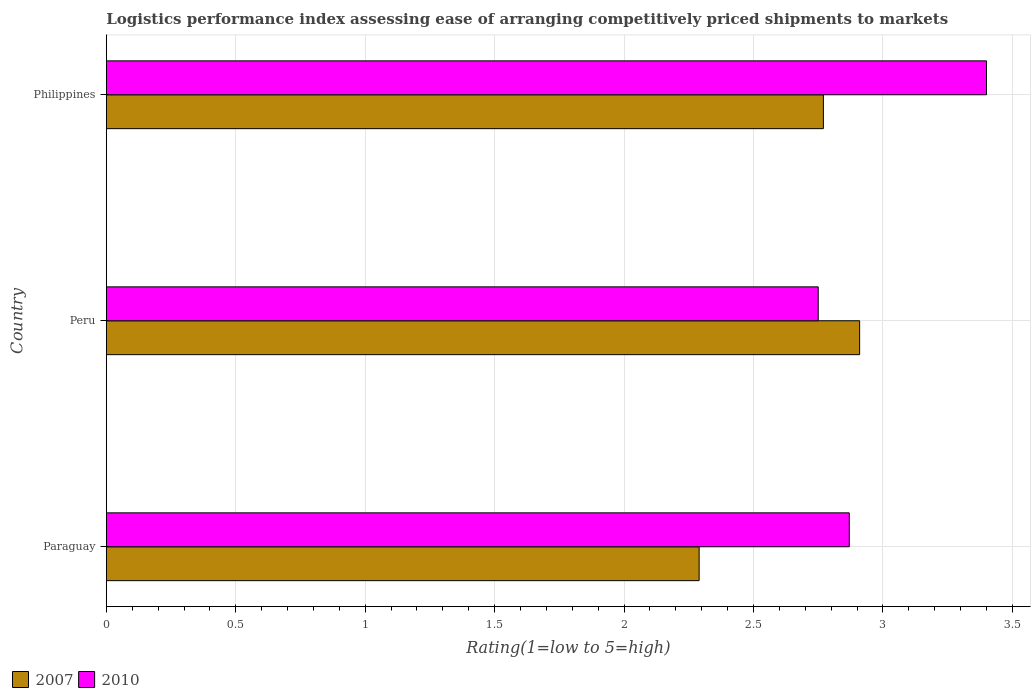Are the number of bars per tick equal to the number of legend labels?
Offer a very short reply. Yes. Are the number of bars on each tick of the Y-axis equal?
Offer a very short reply. Yes. How many bars are there on the 3rd tick from the top?
Give a very brief answer. 2. How many bars are there on the 3rd tick from the bottom?
Make the answer very short. 2. What is the label of the 3rd group of bars from the top?
Provide a succinct answer. Paraguay. What is the Logistic performance index in 2007 in Philippines?
Make the answer very short. 2.77. Across all countries, what is the minimum Logistic performance index in 2007?
Your answer should be compact. 2.29. In which country was the Logistic performance index in 2010 minimum?
Make the answer very short. Peru. What is the total Logistic performance index in 2010 in the graph?
Offer a very short reply. 9.02. What is the difference between the Logistic performance index in 2010 in Peru and that in Philippines?
Provide a succinct answer. -0.65. What is the difference between the Logistic performance index in 2007 in Paraguay and the Logistic performance index in 2010 in Peru?
Provide a short and direct response. -0.46. What is the average Logistic performance index in 2010 per country?
Provide a short and direct response. 3.01. What is the difference between the Logistic performance index in 2010 and Logistic performance index in 2007 in Philippines?
Make the answer very short. 0.63. What is the ratio of the Logistic performance index in 2010 in Paraguay to that in Peru?
Your response must be concise. 1.04. Is the Logistic performance index in 2007 in Peru less than that in Philippines?
Make the answer very short. No. What is the difference between the highest and the second highest Logistic performance index in 2007?
Ensure brevity in your answer.  0.14. What is the difference between the highest and the lowest Logistic performance index in 2007?
Your response must be concise. 0.62. In how many countries, is the Logistic performance index in 2010 greater than the average Logistic performance index in 2010 taken over all countries?
Give a very brief answer. 1. How many bars are there?
Offer a terse response. 6. How many countries are there in the graph?
Your answer should be very brief. 3. What is the difference between two consecutive major ticks on the X-axis?
Ensure brevity in your answer.  0.5. Does the graph contain grids?
Ensure brevity in your answer.  Yes. Where does the legend appear in the graph?
Keep it short and to the point. Bottom left. How many legend labels are there?
Keep it short and to the point. 2. What is the title of the graph?
Your response must be concise. Logistics performance index assessing ease of arranging competitively priced shipments to markets. What is the label or title of the X-axis?
Your answer should be compact. Rating(1=low to 5=high). What is the Rating(1=low to 5=high) of 2007 in Paraguay?
Provide a succinct answer. 2.29. What is the Rating(1=low to 5=high) of 2010 in Paraguay?
Your answer should be very brief. 2.87. What is the Rating(1=low to 5=high) in 2007 in Peru?
Your response must be concise. 2.91. What is the Rating(1=low to 5=high) of 2010 in Peru?
Your response must be concise. 2.75. What is the Rating(1=low to 5=high) in 2007 in Philippines?
Offer a very short reply. 2.77. Across all countries, what is the maximum Rating(1=low to 5=high) of 2007?
Your answer should be compact. 2.91. Across all countries, what is the maximum Rating(1=low to 5=high) of 2010?
Offer a very short reply. 3.4. Across all countries, what is the minimum Rating(1=low to 5=high) of 2007?
Your answer should be very brief. 2.29. Across all countries, what is the minimum Rating(1=low to 5=high) of 2010?
Offer a very short reply. 2.75. What is the total Rating(1=low to 5=high) of 2007 in the graph?
Make the answer very short. 7.97. What is the total Rating(1=low to 5=high) in 2010 in the graph?
Keep it short and to the point. 9.02. What is the difference between the Rating(1=low to 5=high) of 2007 in Paraguay and that in Peru?
Provide a short and direct response. -0.62. What is the difference between the Rating(1=low to 5=high) of 2010 in Paraguay and that in Peru?
Give a very brief answer. 0.12. What is the difference between the Rating(1=low to 5=high) in 2007 in Paraguay and that in Philippines?
Your response must be concise. -0.48. What is the difference between the Rating(1=low to 5=high) in 2010 in Paraguay and that in Philippines?
Provide a succinct answer. -0.53. What is the difference between the Rating(1=low to 5=high) of 2007 in Peru and that in Philippines?
Your answer should be very brief. 0.14. What is the difference between the Rating(1=low to 5=high) in 2010 in Peru and that in Philippines?
Provide a short and direct response. -0.65. What is the difference between the Rating(1=low to 5=high) in 2007 in Paraguay and the Rating(1=low to 5=high) in 2010 in Peru?
Provide a succinct answer. -0.46. What is the difference between the Rating(1=low to 5=high) in 2007 in Paraguay and the Rating(1=low to 5=high) in 2010 in Philippines?
Keep it short and to the point. -1.11. What is the difference between the Rating(1=low to 5=high) of 2007 in Peru and the Rating(1=low to 5=high) of 2010 in Philippines?
Provide a short and direct response. -0.49. What is the average Rating(1=low to 5=high) of 2007 per country?
Provide a succinct answer. 2.66. What is the average Rating(1=low to 5=high) of 2010 per country?
Your answer should be compact. 3.01. What is the difference between the Rating(1=low to 5=high) of 2007 and Rating(1=low to 5=high) of 2010 in Paraguay?
Your response must be concise. -0.58. What is the difference between the Rating(1=low to 5=high) of 2007 and Rating(1=low to 5=high) of 2010 in Peru?
Keep it short and to the point. 0.16. What is the difference between the Rating(1=low to 5=high) of 2007 and Rating(1=low to 5=high) of 2010 in Philippines?
Ensure brevity in your answer.  -0.63. What is the ratio of the Rating(1=low to 5=high) of 2007 in Paraguay to that in Peru?
Give a very brief answer. 0.79. What is the ratio of the Rating(1=low to 5=high) of 2010 in Paraguay to that in Peru?
Your answer should be very brief. 1.04. What is the ratio of the Rating(1=low to 5=high) of 2007 in Paraguay to that in Philippines?
Your response must be concise. 0.83. What is the ratio of the Rating(1=low to 5=high) of 2010 in Paraguay to that in Philippines?
Offer a terse response. 0.84. What is the ratio of the Rating(1=low to 5=high) of 2007 in Peru to that in Philippines?
Your answer should be compact. 1.05. What is the ratio of the Rating(1=low to 5=high) of 2010 in Peru to that in Philippines?
Offer a very short reply. 0.81. What is the difference between the highest and the second highest Rating(1=low to 5=high) in 2007?
Ensure brevity in your answer.  0.14. What is the difference between the highest and the second highest Rating(1=low to 5=high) in 2010?
Offer a terse response. 0.53. What is the difference between the highest and the lowest Rating(1=low to 5=high) in 2007?
Give a very brief answer. 0.62. What is the difference between the highest and the lowest Rating(1=low to 5=high) of 2010?
Offer a terse response. 0.65. 